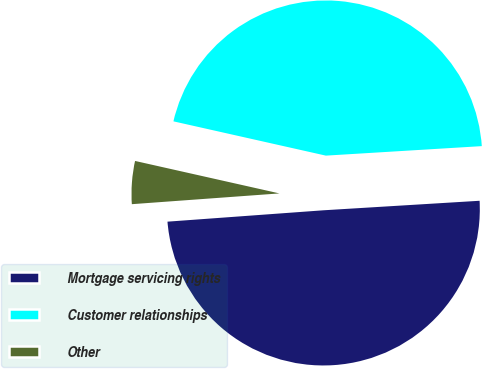Convert chart to OTSL. <chart><loc_0><loc_0><loc_500><loc_500><pie_chart><fcel>Mortgage servicing rights<fcel>Customer relationships<fcel>Other<nl><fcel>49.81%<fcel>45.51%<fcel>4.68%<nl></chart> 